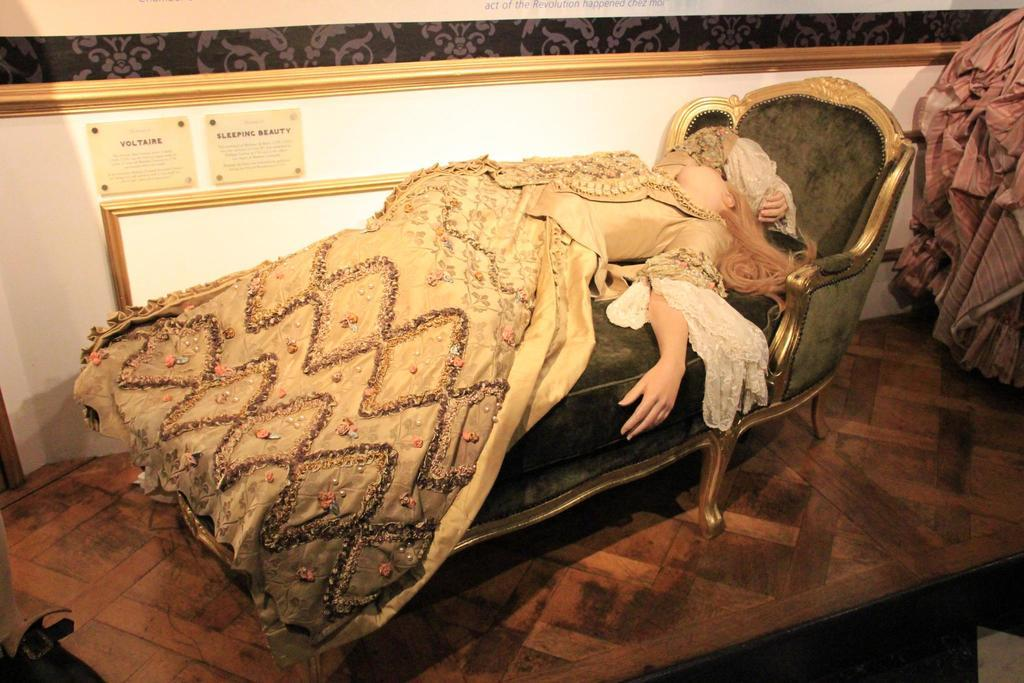Who is present in the image? There is a woman in the image. What is the woman doing in the image? The woman is lying on a sofa. What can be seen in the background of the image? There is a wall visible in the image. What type of sand can be seen on the floor in the image? There is no sand present in the image; it features a woman lying on a sofa with a wall visible in the background. 